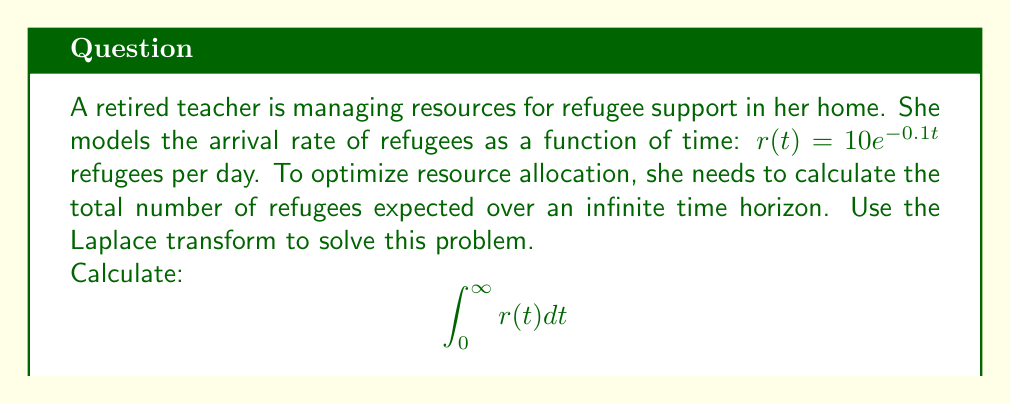Can you solve this math problem? To solve this problem using the Laplace transform, we'll follow these steps:

1) First, recall that the Laplace transform of a function $f(t)$ is defined as:

   $$\mathcal{L}\{f(t)\} = F(s) = \int_0^{\infty} e^{-st}f(t) dt$$

2) In our case, we want to calculate $\int_0^{\infty} r(t) dt$, which is equivalent to finding $\lim_{s \to 0} \mathcal{L}\{r(t)\}$.

3) Let's find the Laplace transform of $r(t) = 10e^{-0.1t}$:

   $$\mathcal{L}\{r(t)\} = \int_0^{\infty} e^{-st}(10e^{-0.1t}) dt = 10\int_0^{\infty} e^{-(s+0.1)t} dt$$

4) Evaluating this integral:

   $$\mathcal{L}\{r(t)\} = 10 \cdot \frac{1}{s+0.1}$$

5) Now, to find the total number of refugees over an infinite time horizon, we take the limit as $s$ approaches 0:

   $$\lim_{s \to 0} \mathcal{L}\{r(t)\} = \lim_{s \to 0} \frac{10}{s+0.1} = \frac{10}{0.1} = 100$$

Thus, the total expected number of refugees over an infinite time horizon is 100.
Answer: 100 refugees 